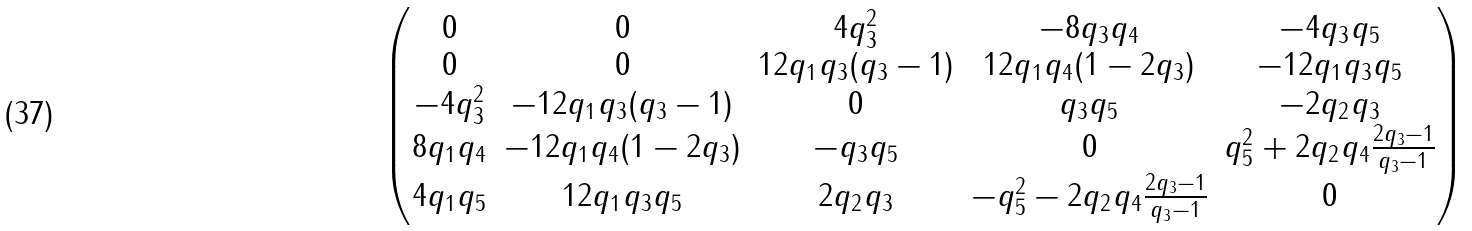Convert formula to latex. <formula><loc_0><loc_0><loc_500><loc_500>\begin{pmatrix} 0 & 0 & 4 q _ { 3 } ^ { 2 } & - 8 q _ { 3 } q _ { 4 } & - 4 q _ { 3 } q _ { 5 } \\ 0 & 0 & 1 2 q _ { 1 } q _ { 3 } ( q _ { 3 } - 1 ) & 1 2 q _ { 1 } q _ { 4 } ( 1 - 2 q _ { 3 } ) & - 1 2 q _ { 1 } q _ { 3 } q _ { 5 } \\ - 4 q _ { 3 } ^ { 2 } & - 1 2 q _ { 1 } q _ { 3 } ( q _ { 3 } - 1 ) & 0 & q _ { 3 } q _ { 5 } & - 2 q _ { 2 } q _ { 3 } \\ 8 q _ { 1 } q _ { 4 } & - 1 2 q _ { 1 } q _ { 4 } ( 1 - 2 q _ { 3 } ) & - q _ { 3 } q _ { 5 } & 0 & q _ { 5 } ^ { 2 } + 2 q _ { 2 } q _ { 4 } \frac { 2 q _ { 3 } - 1 } { q _ { 3 } - 1 } \\ 4 q _ { 1 } q _ { 5 } & 1 2 q _ { 1 } q _ { 3 } q _ { 5 } & 2 q _ { 2 } q _ { 3 } & - q _ { 5 } ^ { 2 } - 2 q _ { 2 } q _ { 4 } \frac { 2 q _ { 3 } - 1 } { q _ { 3 } - 1 } & 0 \end{pmatrix}</formula> 